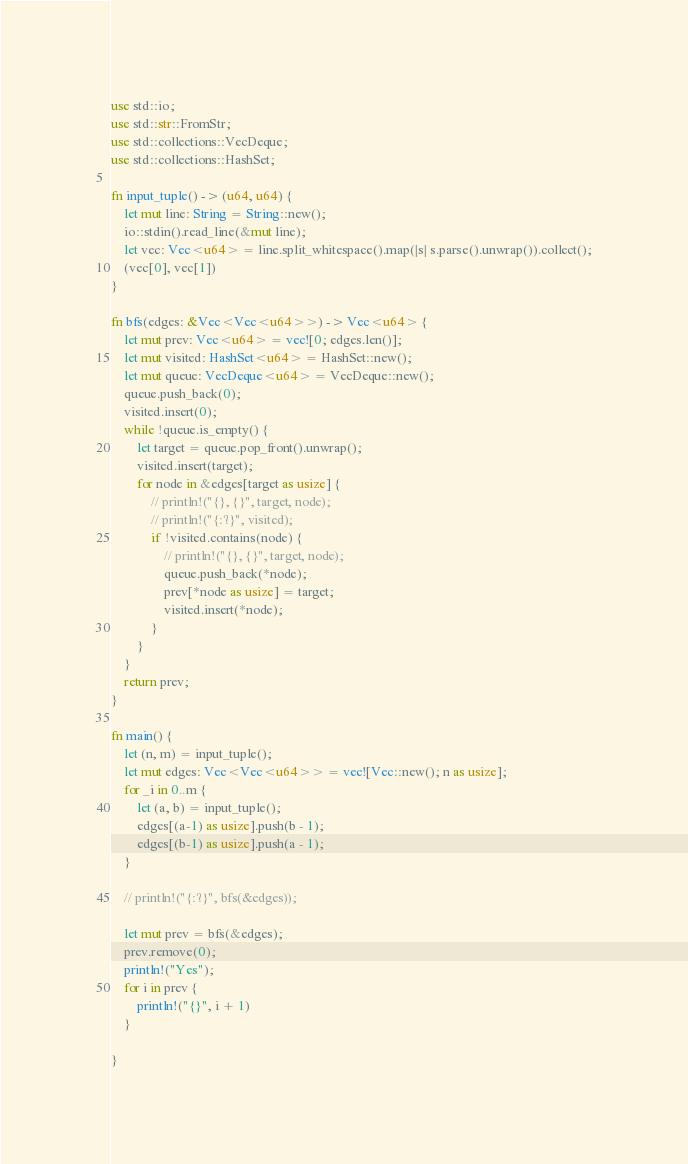<code> <loc_0><loc_0><loc_500><loc_500><_Rust_>use std::io;
use std::str::FromStr;
use std::collections::VecDeque;
use std::collections::HashSet;

fn input_tuple() -> (u64, u64) {
    let mut line: String = String::new();
    io::stdin().read_line(&mut line);
    let vec: Vec<u64> = line.split_whitespace().map(|s| s.parse().unwrap()).collect();
    (vec[0], vec[1])
}

fn bfs(edges: &Vec<Vec<u64>>) -> Vec<u64> {
    let mut prev: Vec<u64> = vec![0; edges.len()];
    let mut visited: HashSet<u64> = HashSet::new();
    let mut queue: VecDeque<u64> = VecDeque::new();
    queue.push_back(0);
    visited.insert(0);
    while !queue.is_empty() {
        let target = queue.pop_front().unwrap();
        visited.insert(target);
        for node in &edges[target as usize] {
            // println!("{}, {}", target, node);
            // println!("{:?}", visited);
            if !visited.contains(node) {
                // println!("{}, {}", target, node);
                queue.push_back(*node);
                prev[*node as usize] = target;
                visited.insert(*node);
            }   
        }
    }
    return prev;
}

fn main() {
    let (n, m) = input_tuple();
    let mut edges: Vec<Vec<u64>> = vec![Vec::new(); n as usize];
    for _i in 0..m {
        let (a, b) = input_tuple();
        edges[(a-1) as usize].push(b - 1);
        edges[(b-1) as usize].push(a - 1);
    }

    // println!("{:?}", bfs(&edges));

    let mut prev = bfs(&edges);
    prev.remove(0);
    println!("Yes");
    for i in prev {
        println!("{}", i + 1)
    }

}
</code> 